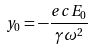Convert formula to latex. <formula><loc_0><loc_0><loc_500><loc_500>y _ { 0 } = - \frac { e c E _ { 0 } } { \gamma \omega ^ { 2 } }</formula> 